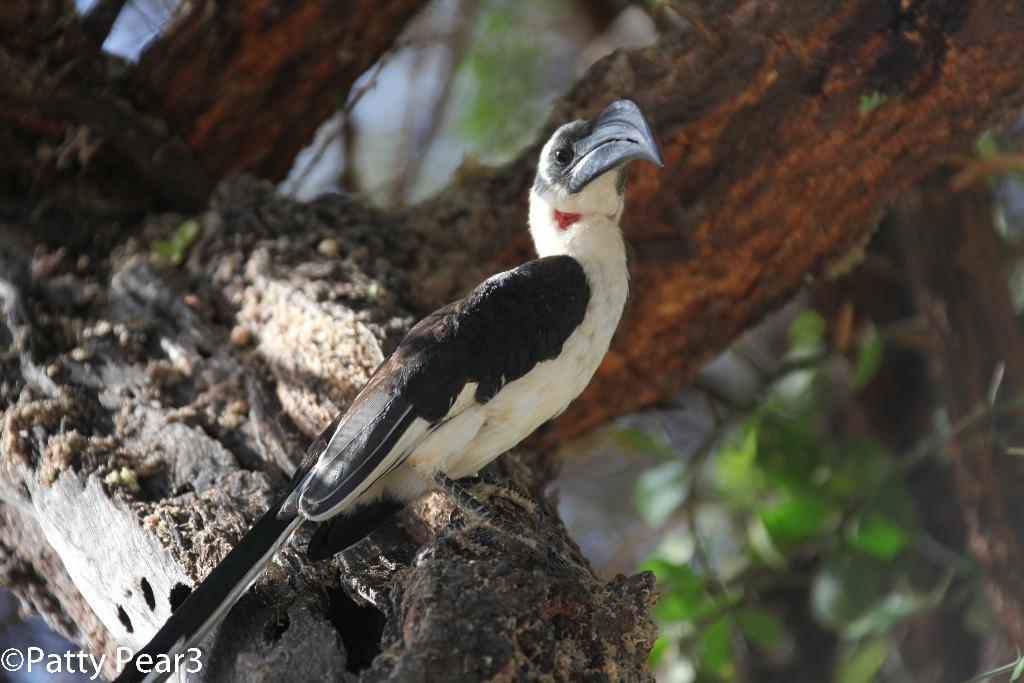What type of setting is depicted in the image? The image is an outdoor scene. What can be seen in the background of the image? There is a branch of a tree in the background of the image. What animal is present in the image? There is a bird in the image. Where is the bird located in the image? The bird is on the branch of a tree. What color is the ink used to draw the bird in the image? There is no ink present in the image, as it is a photograph of a real bird on a tree branch. 